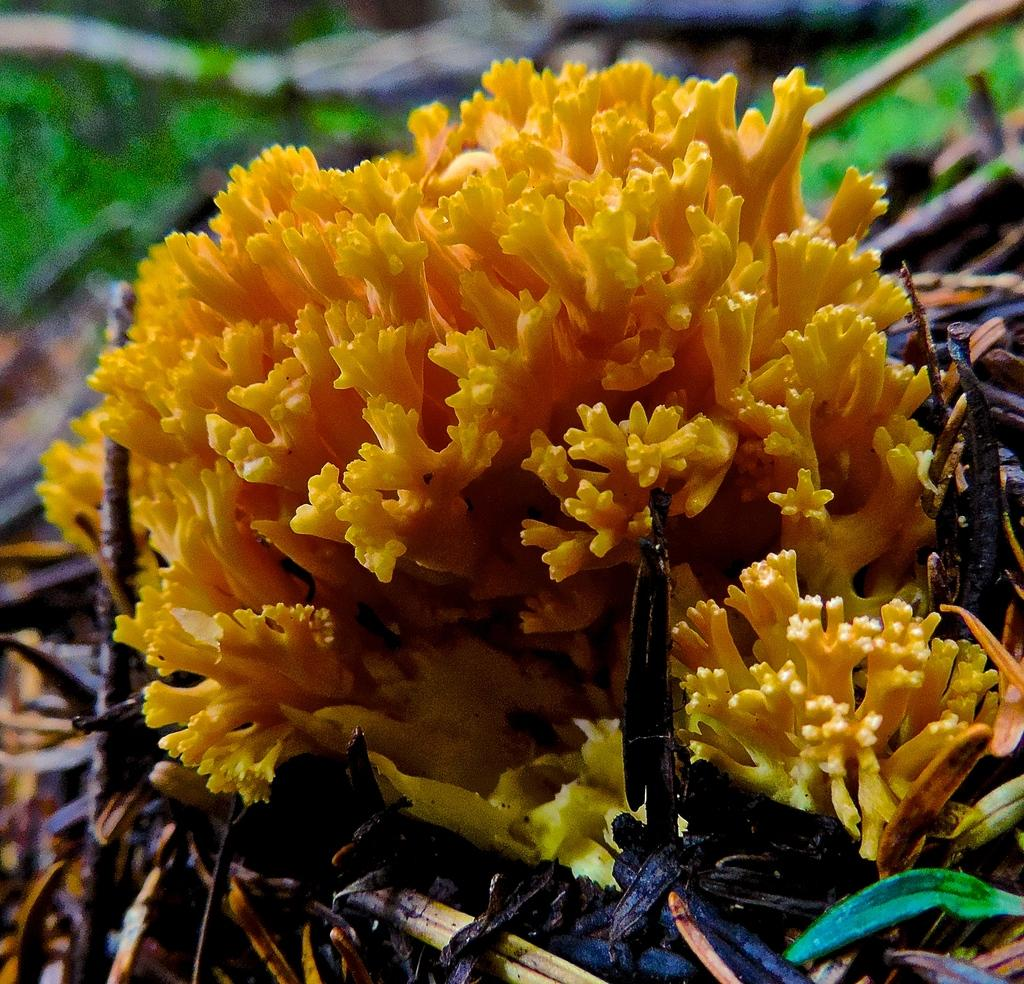What is the main subject of the image? There is a flower in the image. What else can be seen in the image besides the flower? There are leaves in the image. How would you describe the background of the image? The background of the image is blurry. What type of discussion is taking place between the flower and the leaves in the image? There is no discussion taking place between the flower and the leaves in the image, as they are inanimate objects and cannot engage in conversation. 